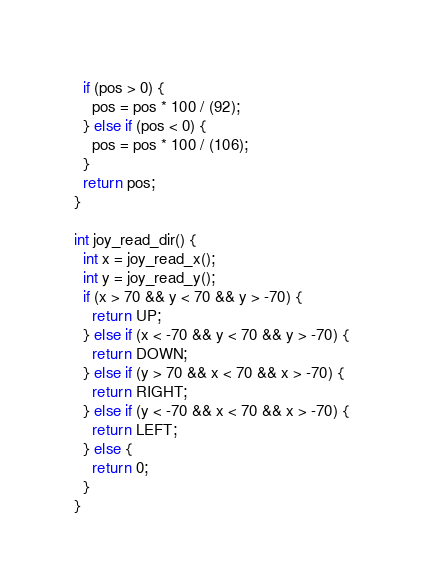<code> <loc_0><loc_0><loc_500><loc_500><_C_>  if (pos > 0) {
    pos = pos * 100 / (92);
  } else if (pos < 0) {
    pos = pos * 100 / (106);
  }
  return pos;
}

int joy_read_dir() {
  int x = joy_read_x();
  int y = joy_read_y();
  if (x > 70 && y < 70 && y > -70) {
    return UP;
  } else if (x < -70 && y < 70 && y > -70) {
    return DOWN;
  } else if (y > 70 && x < 70 && x > -70) {
    return RIGHT;
  } else if (y < -70 && x < 70 && x > -70) {
    return LEFT;
  } else {
    return 0;
  }
}
</code> 